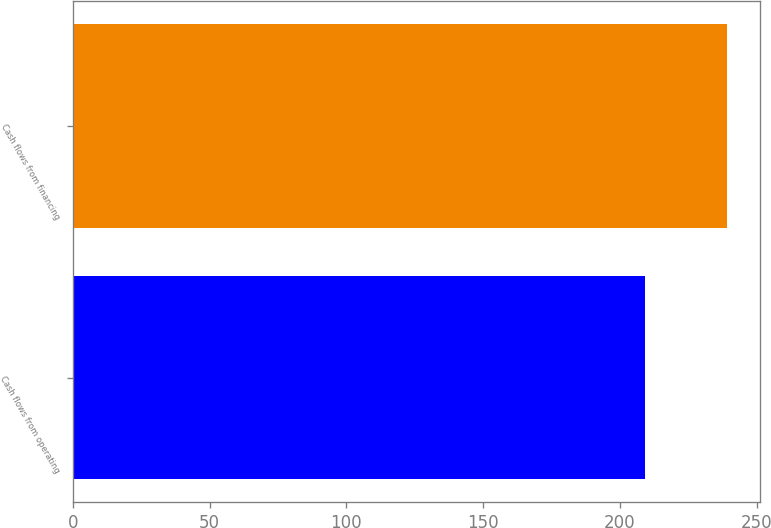Convert chart. <chart><loc_0><loc_0><loc_500><loc_500><bar_chart><fcel>Cash flows from operating<fcel>Cash flows from financing<nl><fcel>209.3<fcel>239.3<nl></chart> 